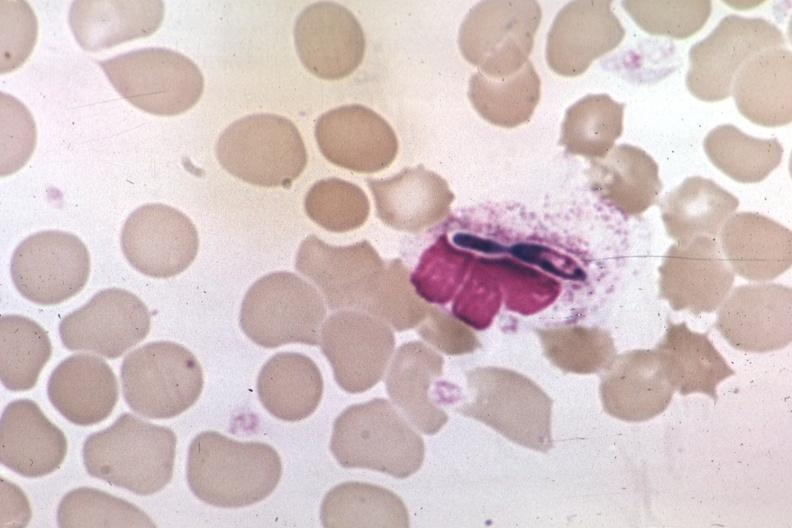what is present?
Answer the question using a single word or phrase. Hematologic 